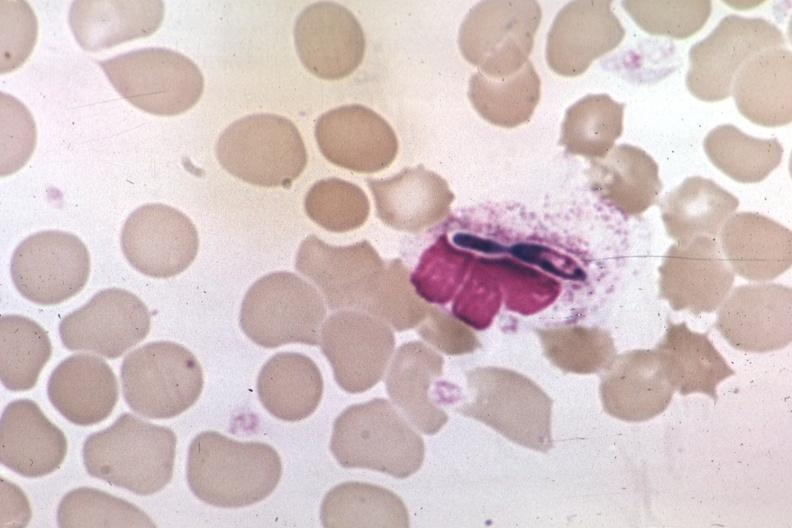what is present?
Answer the question using a single word or phrase. Hematologic 